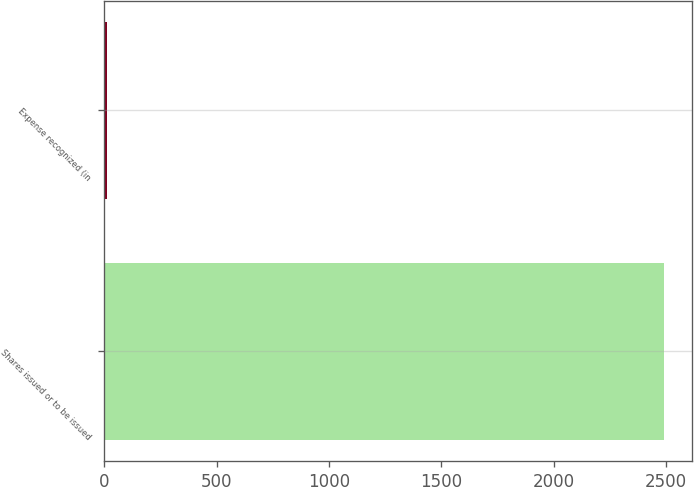Convert chart to OTSL. <chart><loc_0><loc_0><loc_500><loc_500><bar_chart><fcel>Shares issued or to be issued<fcel>Expense recognized (in<nl><fcel>2491<fcel>13<nl></chart> 